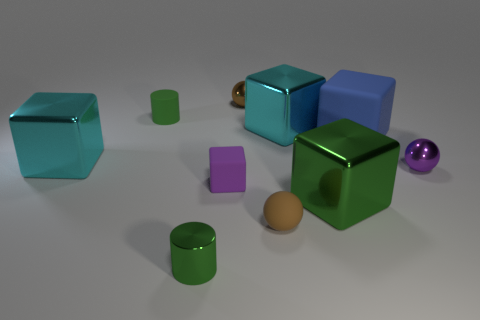There is a metallic cube that is both right of the small metal cylinder and behind the purple metal object; what is its color?
Your response must be concise. Cyan. Is there any other thing that has the same material as the tiny purple ball?
Your response must be concise. Yes. Are the big blue cube and the brown object that is behind the tiny brown matte sphere made of the same material?
Ensure brevity in your answer.  No. There is a green cylinder that is behind the cylinder that is in front of the brown matte sphere; what is its size?
Ensure brevity in your answer.  Small. Are there any other things that are the same color as the matte cylinder?
Provide a short and direct response. Yes. Does the small brown sphere behind the rubber cylinder have the same material as the big blue object on the right side of the brown rubber ball?
Your response must be concise. No. What material is the thing that is in front of the green rubber thing and to the left of the tiny green shiny object?
Give a very brief answer. Metal. Is the shape of the brown shiny thing the same as the brown thing that is in front of the large green shiny thing?
Keep it short and to the point. Yes. The green thing that is behind the large object that is in front of the purple sphere that is to the right of the matte ball is made of what material?
Make the answer very short. Rubber. What number of other things are the same size as the blue cube?
Your answer should be very brief. 3. 